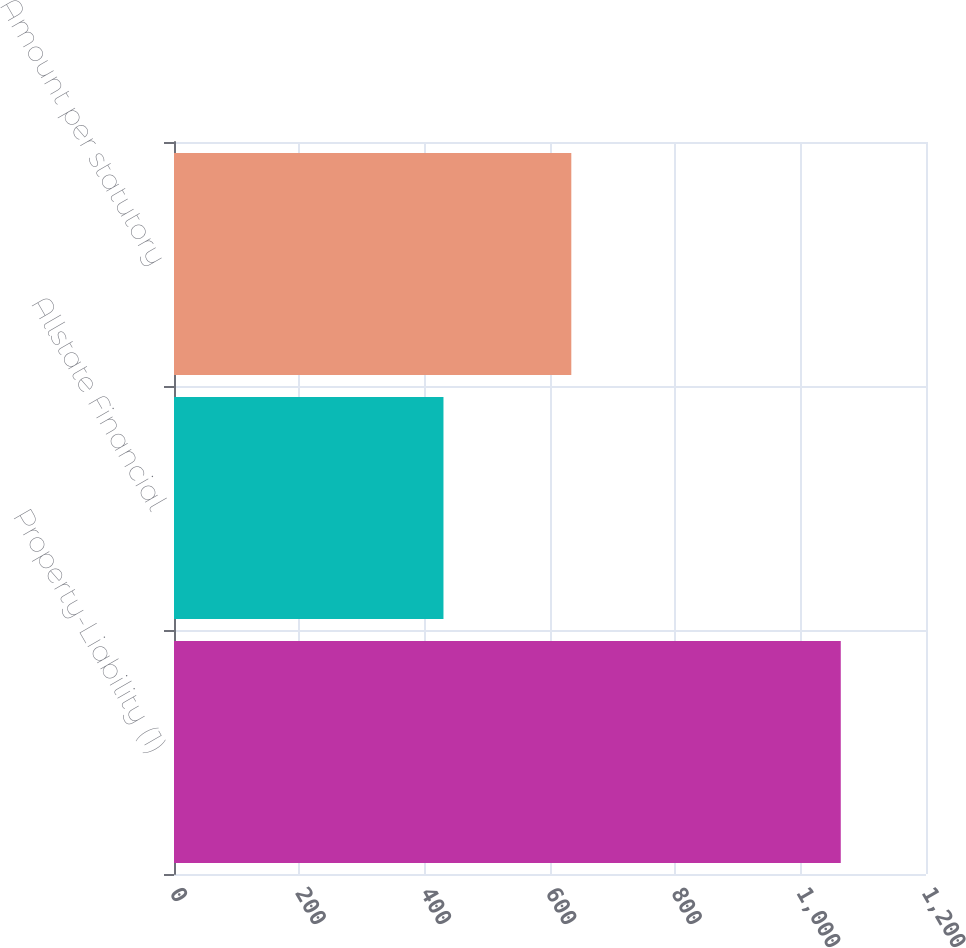Convert chart to OTSL. <chart><loc_0><loc_0><loc_500><loc_500><bar_chart><fcel>Property-Liability (1)<fcel>Allstate Financial<fcel>Amount per statutory<nl><fcel>1064<fcel>430<fcel>634<nl></chart> 